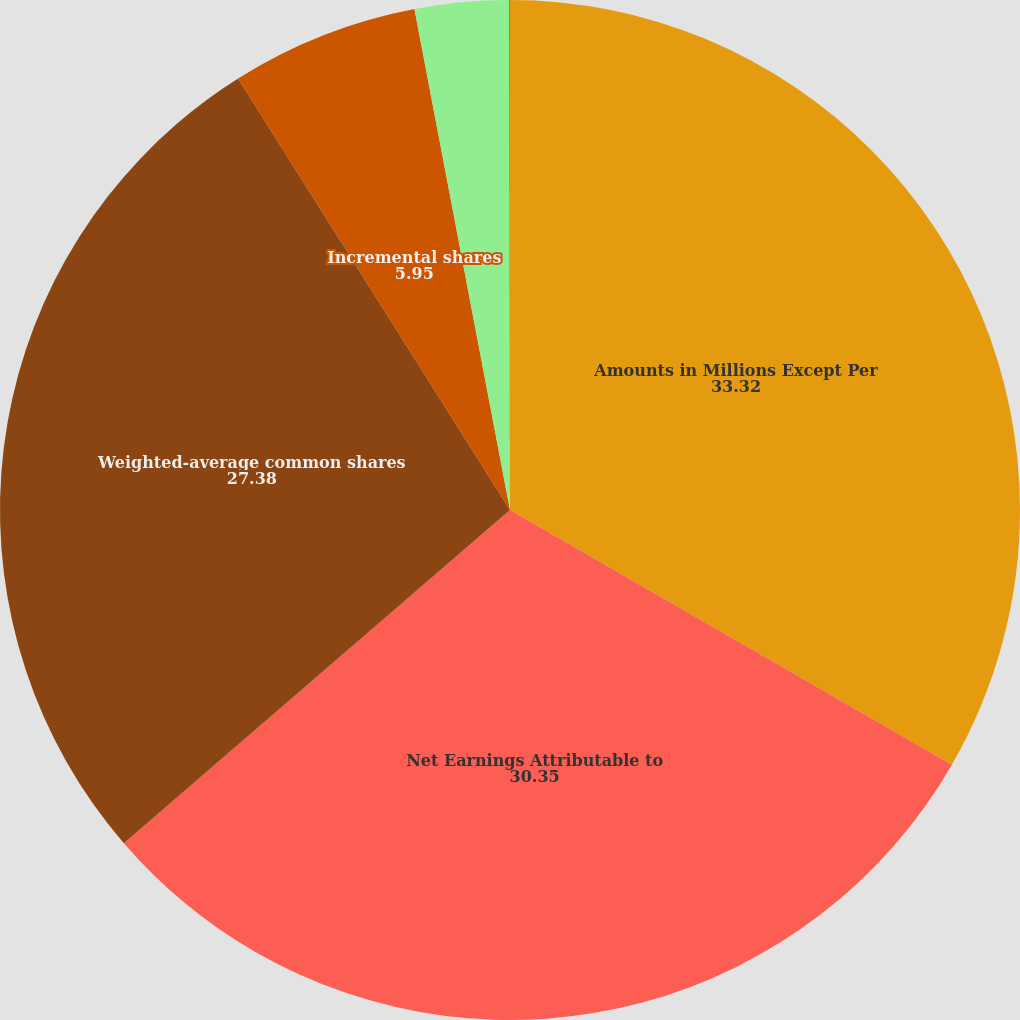Convert chart to OTSL. <chart><loc_0><loc_0><loc_500><loc_500><pie_chart><fcel>Amounts in Millions Except Per<fcel>Net Earnings Attributable to<fcel>Weighted-average common shares<fcel>Incremental shares<fcel>Earnings per share - basic<fcel>Earnings per share - diluted<nl><fcel>33.32%<fcel>30.35%<fcel>27.38%<fcel>5.95%<fcel>2.98%<fcel>0.02%<nl></chart> 